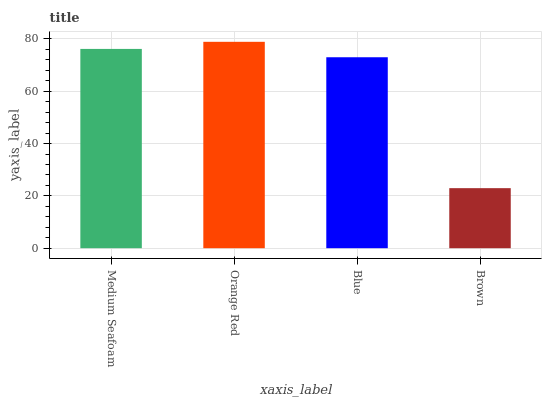Is Brown the minimum?
Answer yes or no. Yes. Is Orange Red the maximum?
Answer yes or no. Yes. Is Blue the minimum?
Answer yes or no. No. Is Blue the maximum?
Answer yes or no. No. Is Orange Red greater than Blue?
Answer yes or no. Yes. Is Blue less than Orange Red?
Answer yes or no. Yes. Is Blue greater than Orange Red?
Answer yes or no. No. Is Orange Red less than Blue?
Answer yes or no. No. Is Medium Seafoam the high median?
Answer yes or no. Yes. Is Blue the low median?
Answer yes or no. Yes. Is Orange Red the high median?
Answer yes or no. No. Is Orange Red the low median?
Answer yes or no. No. 